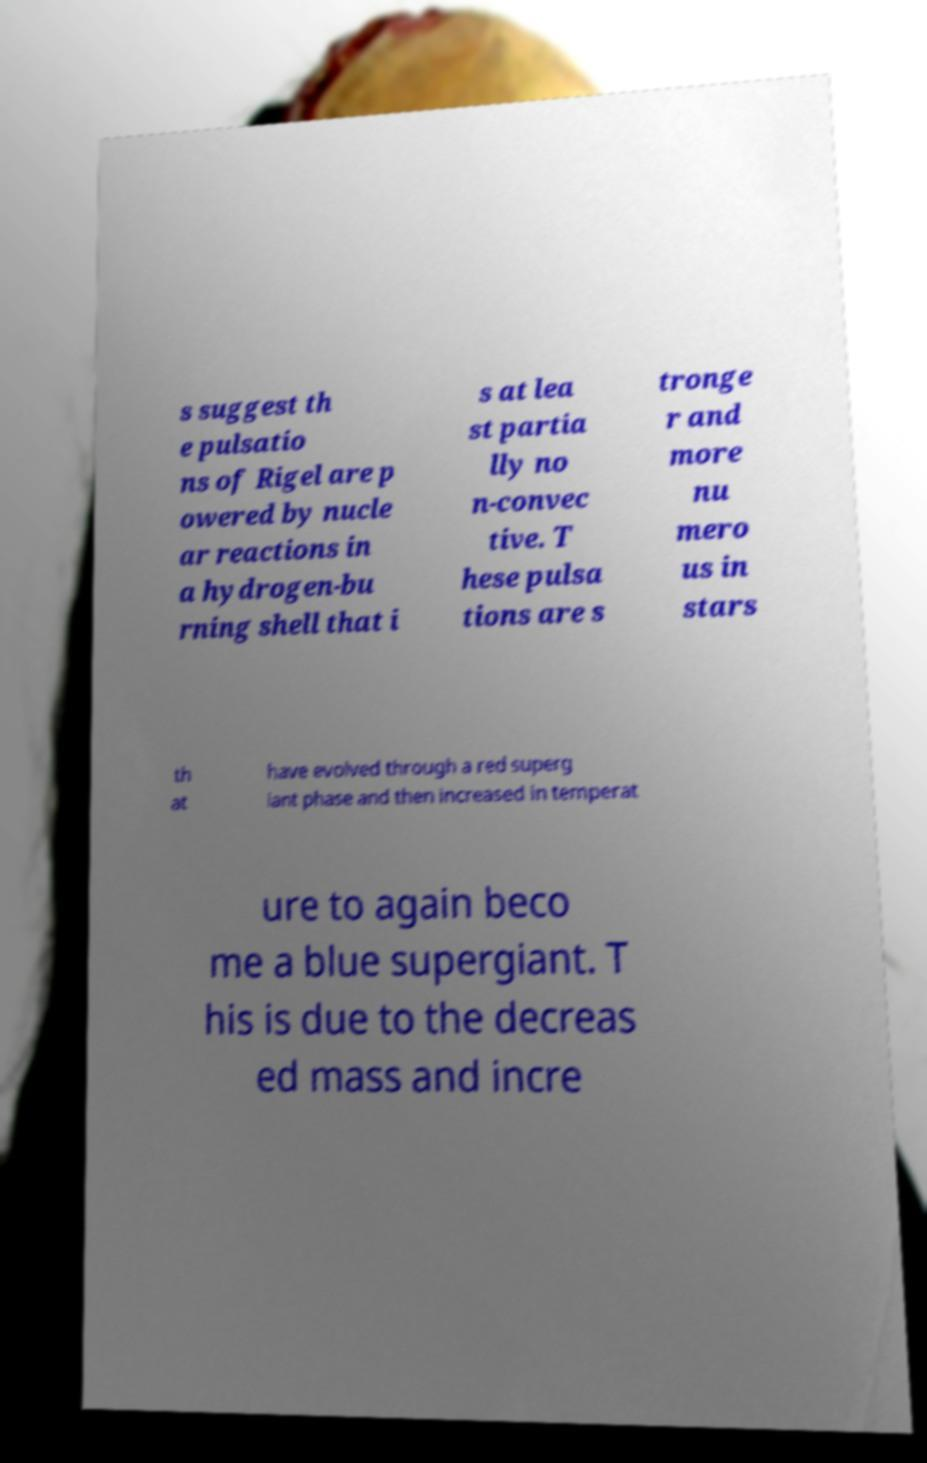For documentation purposes, I need the text within this image transcribed. Could you provide that? s suggest th e pulsatio ns of Rigel are p owered by nucle ar reactions in a hydrogen-bu rning shell that i s at lea st partia lly no n-convec tive. T hese pulsa tions are s tronge r and more nu mero us in stars th at have evolved through a red superg iant phase and then increased in temperat ure to again beco me a blue supergiant. T his is due to the decreas ed mass and incre 